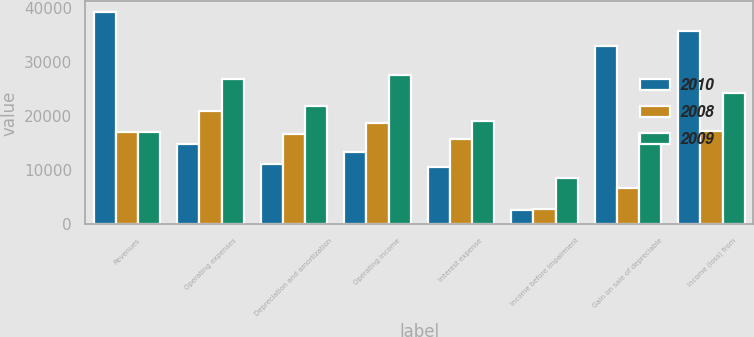Convert chart to OTSL. <chart><loc_0><loc_0><loc_500><loc_500><stacked_bar_chart><ecel><fcel>Revenues<fcel>Operating expenses<fcel>Depreciation and amortization<fcel>Operating income<fcel>Interest expense<fcel>Income before impairment<fcel>Gain on sale of depreciable<fcel>Income (loss) from<nl><fcel>2010<fcel>39325<fcel>14893<fcel>11120<fcel>13312<fcel>10580<fcel>2732<fcel>33054<fcel>35786<nl><fcel>2008<fcel>17113<fcel>21008<fcel>16697<fcel>18758<fcel>15873<fcel>2885<fcel>6786<fcel>17265<nl><fcel>2009<fcel>17113<fcel>26990<fcel>21933<fcel>27670<fcel>19124<fcel>8546<fcel>16961<fcel>24241<nl></chart> 